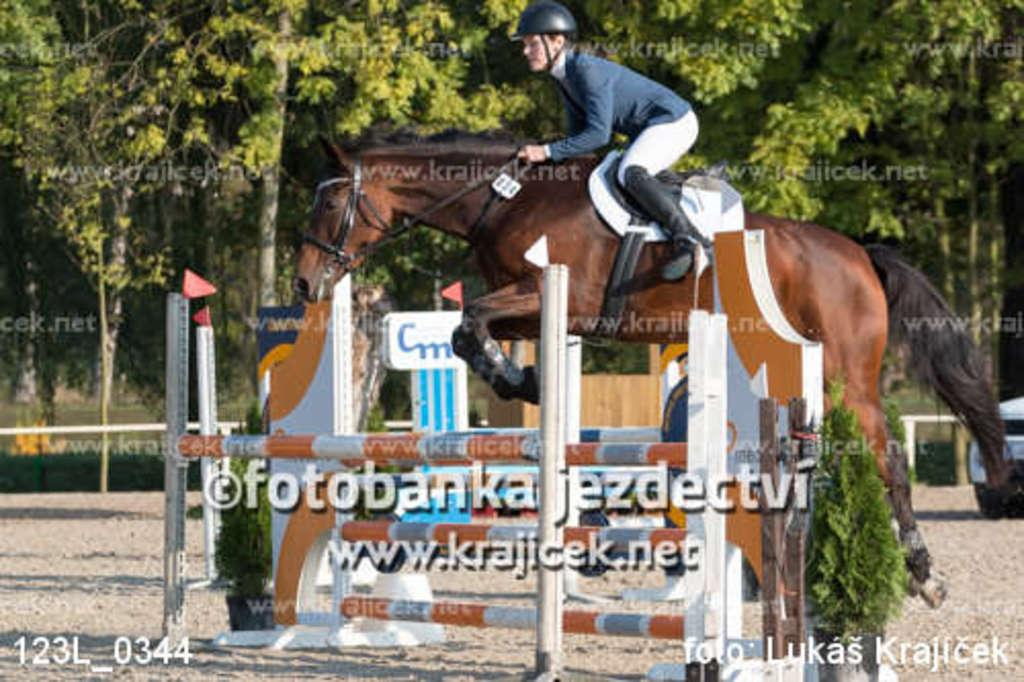What is the main subject of the image? There is a person in the image. What is the person doing in the image? The person is on a horse. What type of vegetation can be seen in the image? There are plants in the image. What can be seen in the background of the image? There are trees in the background of the image. What shape is the visitor taking in the image? There is no visitor present in the image, so it is not possible to determine the shape they might be taking. 